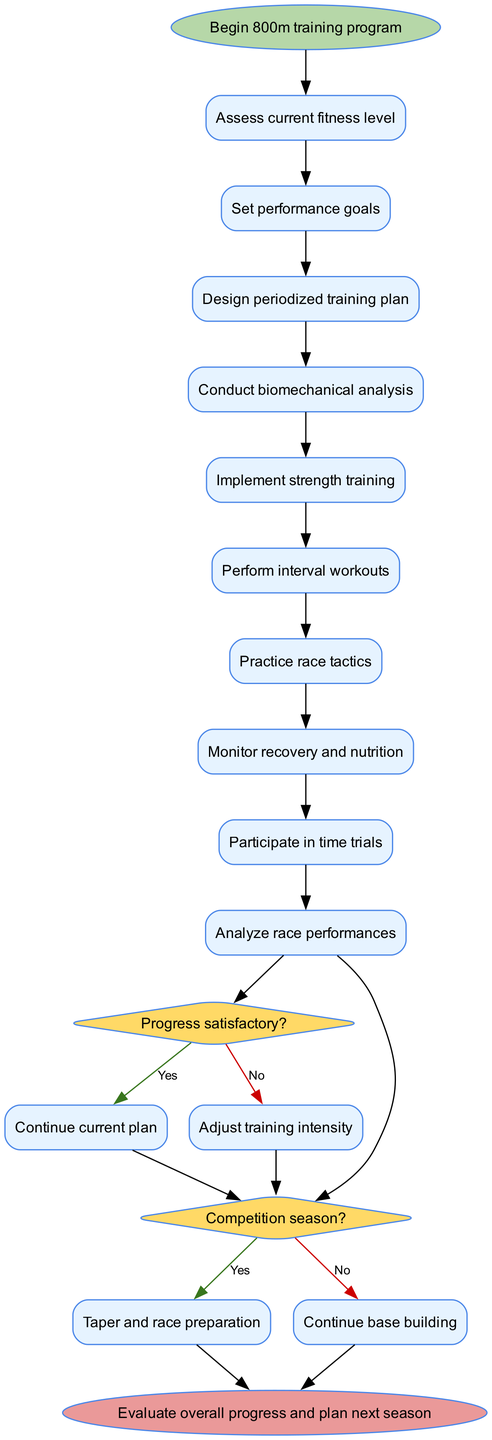What is the starting point of the training program? The start node of the diagram clearly indicates the beginning of the training program for the 800m runner, labeled "Begin 800m training program."
Answer: Begin 800m training program How many activities are included in the training program? By counting the activities listed within the diagram, we find a total of 10 distinct activities that the program incorporates.
Answer: 10 What is the first activity in the training program? Referring to the first node after the start node, the first activity specified is "Assess current fitness level."
Answer: Assess current fitness level What happens if the progress is not satisfactory? The decision node shows that if the progress is deemed not satisfactory, the route diverges to "Adjust training intensity," outlining the action taken.
Answer: Adjust training intensity What is the end point of the training program? The end node of the diagram states that the final step is "Evaluate overall progress and plan next season," indicating the conclusion of the program.
Answer: Evaluate overall progress and plan next season If there is no competition season, what action follows? The diagram specifies that in the absence of a competition season, the next action to be taken is "Continue base building," which is the pathway chosen.
Answer: Continue base building How many decision points are in the diagram? By counting the decision nodes present in the diagram, we can observe there are 2 distinct decision points presented.
Answer: 2 How many edges lead to the end of the diagram? Analyzing the edges connecting to the end node, both the 'Yes' paths from the last decision lead to it, resulting in a total of 2 edges leading to the end.
Answer: 2 